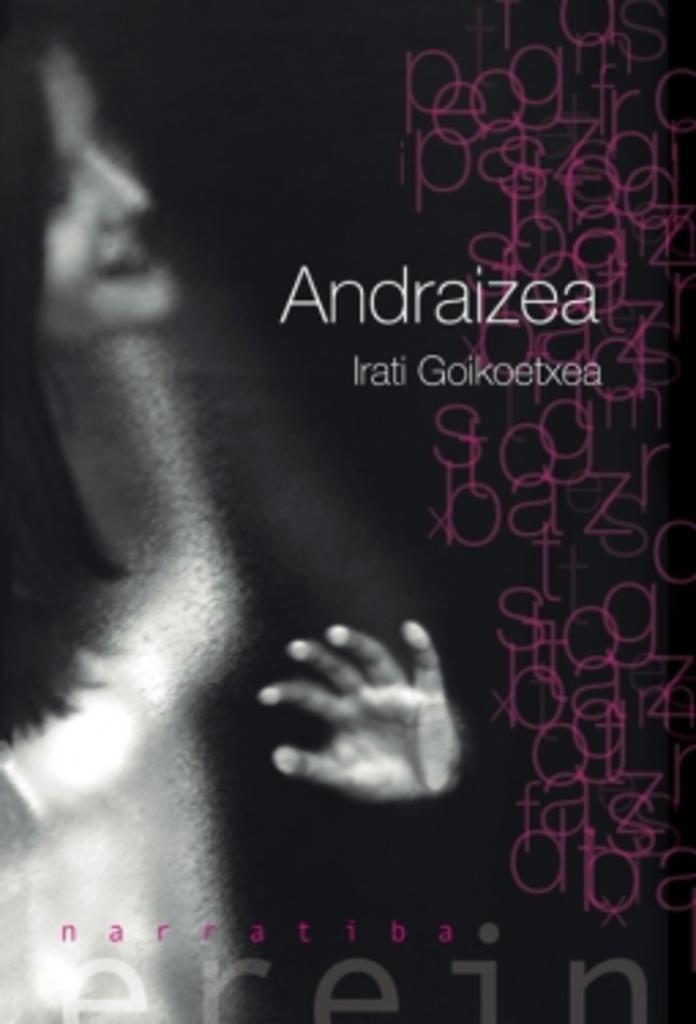Provide a one-sentence caption for the provided image. A cover of a book with overlapping words by Irati. 